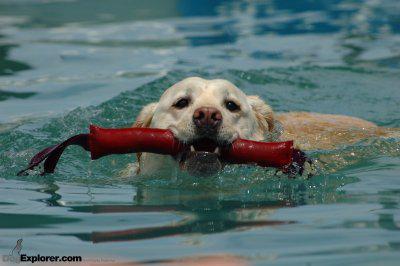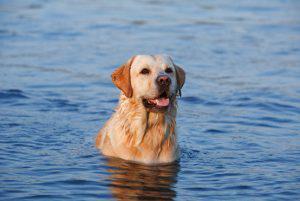The first image is the image on the left, the second image is the image on the right. For the images shown, is this caption "a dog is swimming while carrying something in it's mouth" true? Answer yes or no. Yes. The first image is the image on the left, the second image is the image on the right. For the images displayed, is the sentence "One dog has something in its mouth." factually correct? Answer yes or no. Yes. 